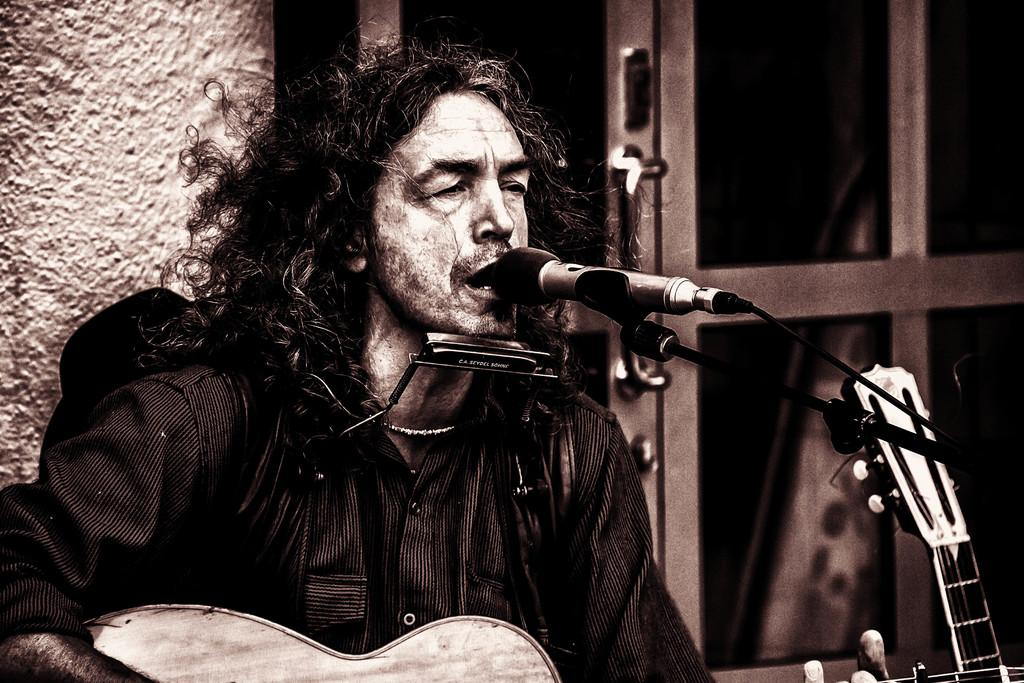What is the man in the image doing? The man is playing a guitar in the image. What object is present that is typically used for amplifying sound? There is a microphone in the image. What type of beetle can be seen crawling on the guitar in the image? There is no beetle present in the image; it only features a man playing a guitar and a microphone. 